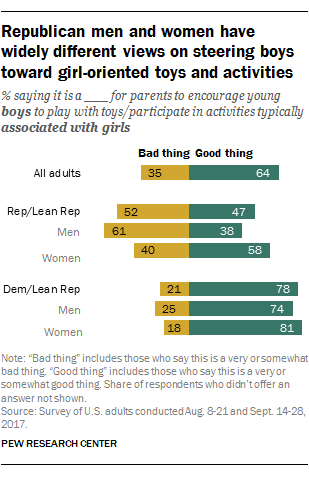Highlight a few significant elements in this photo. The two bars in the chart represent either a bad thing or a good thing. According to the data, the number of positive aspects of Democratic men is greater than the negative aspects, resulting in a rating of 2.96. 